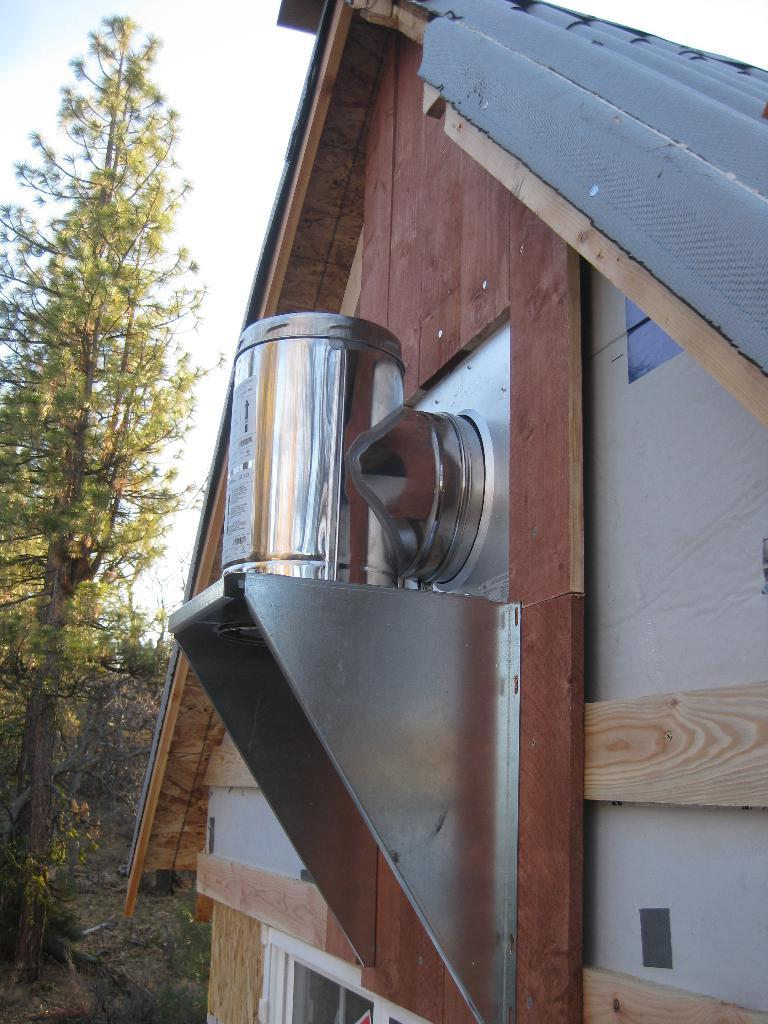What is the main structure in the foreground of the image? A: There is a building in the foreground of the image. What can be seen in the center of the image? There is an iron object in the center of the image. What type of vegetation is on the left side of the image? There are trees on the left side of the image. How does the government affect the iron object in the image? There is no indication of government involvement or influence in the image, and the iron object is not affected by any government actions. What type of brush can be seen interacting with the trees in the image? There is no brush present in the image, and the trees are not being interacted with by any brush. 